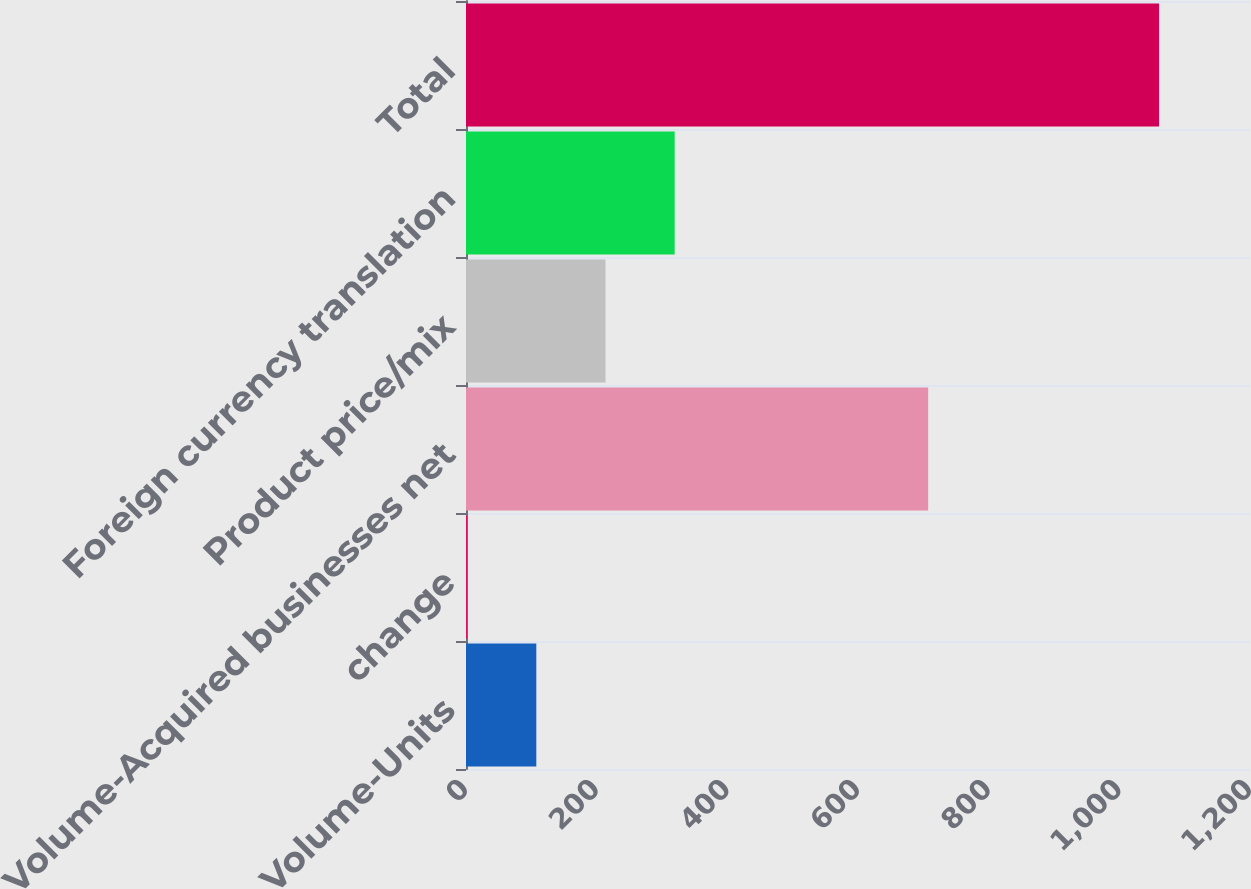Convert chart to OTSL. <chart><loc_0><loc_0><loc_500><loc_500><bar_chart><fcel>Volume-Units<fcel>change<fcel>Volume-Acquired businesses net<fcel>Product price/mix<fcel>Foreign currency translation<fcel>Total<nl><fcel>107.61<fcel>1.7<fcel>707.4<fcel>213.52<fcel>319.43<fcel>1060.8<nl></chart> 